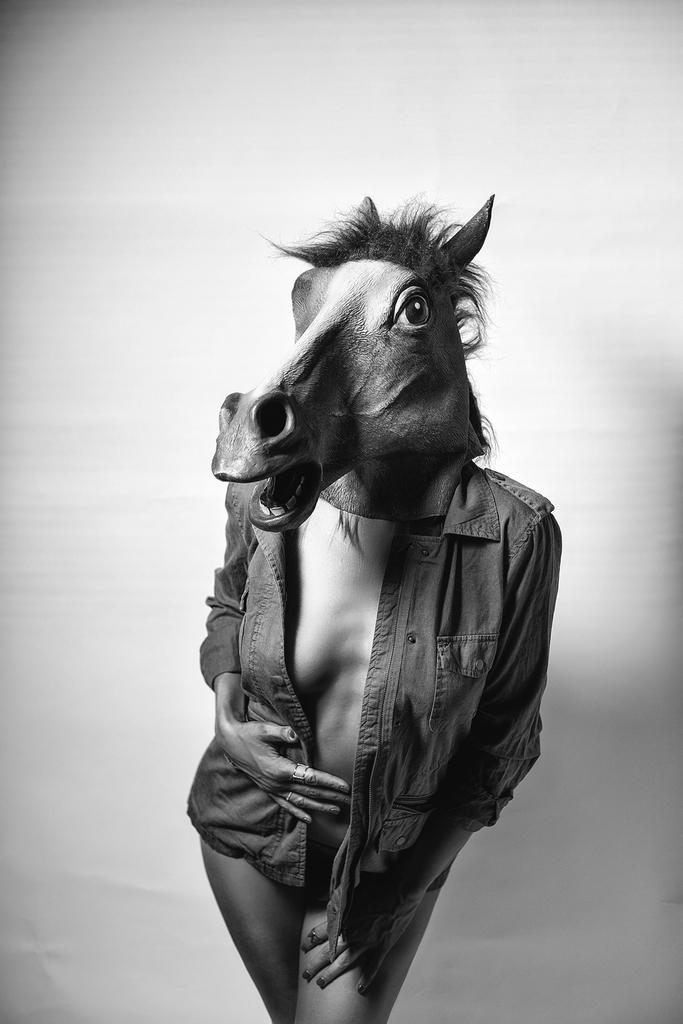What can be seen in the image? There is a person in the image. What is the person wearing on their body? The person is wearing a jacket. What is covering the person's head? The person is wearing an animal mask over their head. Can you describe any accessories the person is wearing? The person has a ring on their finger. What might be the reason for the person's attire being considered inappropriate? The attire of the person is considered inappropriate, but the specific reason cannot be determined from the image. What date is marked on the calendar in the image? There is no calendar present in the image. What wish does the person have for the future? The image does not provide any information about the person's wishes for the future. What attraction is the person visiting in the image? The image does not show the person visiting any attraction. 